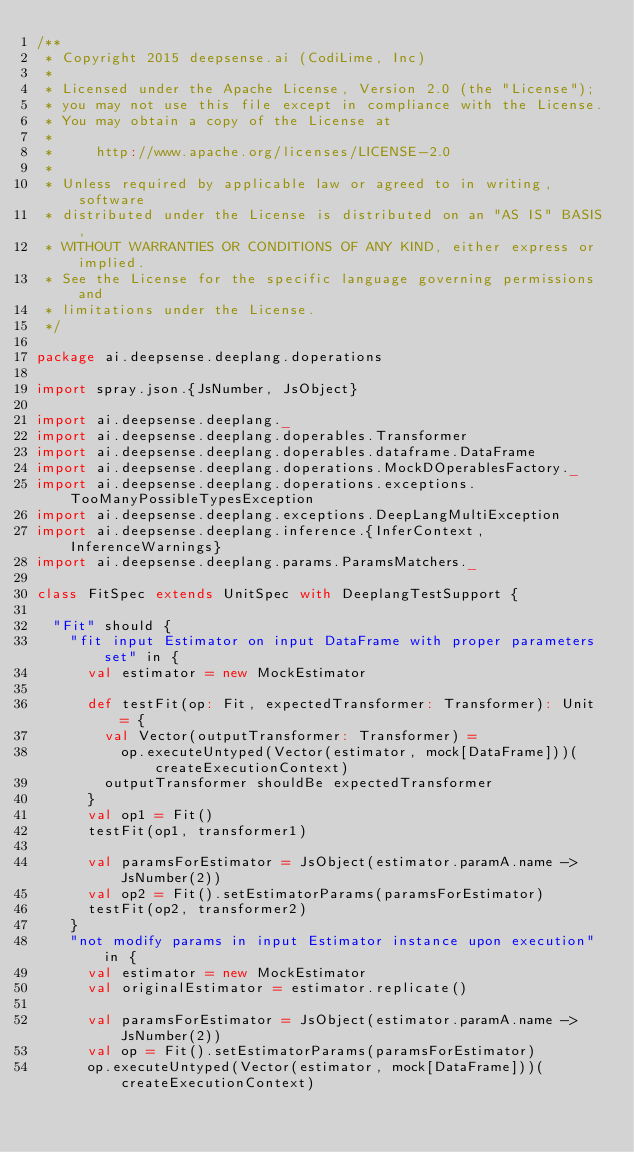Convert code to text. <code><loc_0><loc_0><loc_500><loc_500><_Scala_>/**
 * Copyright 2015 deepsense.ai (CodiLime, Inc)
 *
 * Licensed under the Apache License, Version 2.0 (the "License");
 * you may not use this file except in compliance with the License.
 * You may obtain a copy of the License at
 *
 *     http://www.apache.org/licenses/LICENSE-2.0
 *
 * Unless required by applicable law or agreed to in writing, software
 * distributed under the License is distributed on an "AS IS" BASIS,
 * WITHOUT WARRANTIES OR CONDITIONS OF ANY KIND, either express or implied.
 * See the License for the specific language governing permissions and
 * limitations under the License.
 */

package ai.deepsense.deeplang.doperations

import spray.json.{JsNumber, JsObject}

import ai.deepsense.deeplang._
import ai.deepsense.deeplang.doperables.Transformer
import ai.deepsense.deeplang.doperables.dataframe.DataFrame
import ai.deepsense.deeplang.doperations.MockDOperablesFactory._
import ai.deepsense.deeplang.doperations.exceptions.TooManyPossibleTypesException
import ai.deepsense.deeplang.exceptions.DeepLangMultiException
import ai.deepsense.deeplang.inference.{InferContext, InferenceWarnings}
import ai.deepsense.deeplang.params.ParamsMatchers._

class FitSpec extends UnitSpec with DeeplangTestSupport {

  "Fit" should {
    "fit input Estimator on input DataFrame with proper parameters set" in {
      val estimator = new MockEstimator

      def testFit(op: Fit, expectedTransformer: Transformer): Unit = {
        val Vector(outputTransformer: Transformer) =
          op.executeUntyped(Vector(estimator, mock[DataFrame]))(createExecutionContext)
        outputTransformer shouldBe expectedTransformer
      }
      val op1 = Fit()
      testFit(op1, transformer1)

      val paramsForEstimator = JsObject(estimator.paramA.name -> JsNumber(2))
      val op2 = Fit().setEstimatorParams(paramsForEstimator)
      testFit(op2, transformer2)
    }
    "not modify params in input Estimator instance upon execution" in {
      val estimator = new MockEstimator
      val originalEstimator = estimator.replicate()

      val paramsForEstimator = JsObject(estimator.paramA.name -> JsNumber(2))
      val op = Fit().setEstimatorParams(paramsForEstimator)
      op.executeUntyped(Vector(estimator, mock[DataFrame]))(createExecutionContext)
</code> 